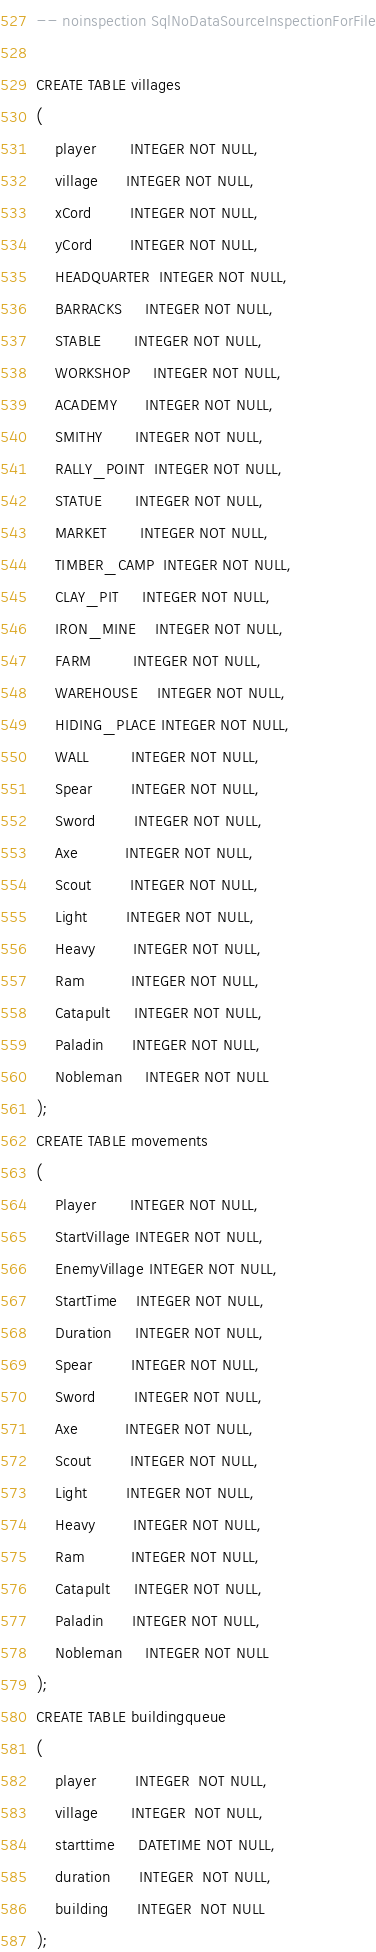<code> <loc_0><loc_0><loc_500><loc_500><_SQL_>-- noinspection SqlNoDataSourceInspectionForFile

CREATE TABLE villages
(
    player       INTEGER NOT NULL,
    village      INTEGER NOT NULL,
    xCord        INTEGER NOT NULL,
    yCord        INTEGER NOT NULL,
    HEADQUARTER  INTEGER NOT NULL,
    BARRACKS     INTEGER NOT NULL,
    STABLE       INTEGER NOT NULL,
    WORKSHOP     INTEGER NOT NULL,
    ACADEMY      INTEGER NOT NULL,
    SMITHY       INTEGER NOT NULL,
    RALLY_POINT  INTEGER NOT NULL,
    STATUE       INTEGER NOT NULL,
    MARKET       INTEGER NOT NULL,
    TIMBER_CAMP  INTEGER NOT NULL,
    CLAY_PIT     INTEGER NOT NULL,
    IRON_MINE    INTEGER NOT NULL,
    FARM         INTEGER NOT NULL,
    WAREHOUSE    INTEGER NOT NULL,
    HIDING_PLACE INTEGER NOT NULL,
    WALL         INTEGER NOT NULL,
    Spear        INTEGER NOT NULL,
    Sword        INTEGER NOT NULL,
    Axe          INTEGER NOT NULL,
    Scout        INTEGER NOT NULL,
    Light        INTEGER NOT NULL,
    Heavy        INTEGER NOT NULL,
    Ram          INTEGER NOT NULL,
    Catapult     INTEGER NOT NULL,
    Paladin      INTEGER NOT NULL,
    Nobleman     INTEGER NOT NULL
);
CREATE TABLE movements
(
    Player       INTEGER NOT NULL,
    StartVillage INTEGER NOT NULL,
    EnemyVillage INTEGER NOT NULL,
    StartTime    INTEGER NOT NULL,
    Duration     INTEGER NOT NULL,
    Spear        INTEGER NOT NULL,
    Sword        INTEGER NOT NULL,
    Axe          INTEGER NOT NULL,
    Scout        INTEGER NOT NULL,
    Light        INTEGER NOT NULL,
    Heavy        INTEGER NOT NULL,
    Ram          INTEGER NOT NULL,
    Catapult     INTEGER NOT NULL,
    Paladin      INTEGER NOT NULL,
    Nobleman     INTEGER NOT NULL
);
CREATE TABLE buildingqueue
(
    player        INTEGER  NOT NULL,
    village       INTEGER  NOT NULL,
    starttime     DATETIME NOT NULL,
    duration      INTEGER  NOT NULL,
    building      INTEGER  NOT NULL
);
</code> 